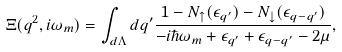Convert formula to latex. <formula><loc_0><loc_0><loc_500><loc_500>\Xi ( q ^ { 2 } , i \omega _ { m } ) = \int _ { d \Lambda } d { q ^ { \prime } } \frac { 1 - N _ { \uparrow } ( \epsilon _ { q ^ { \prime } } ) - N _ { \downarrow } ( \epsilon _ { q - q ^ { \prime } } ) } { - i \hbar { \omega } _ { m } + \epsilon _ { q ^ { \prime } } + \epsilon _ { q - q ^ { \prime } } - 2 \mu } ,</formula> 